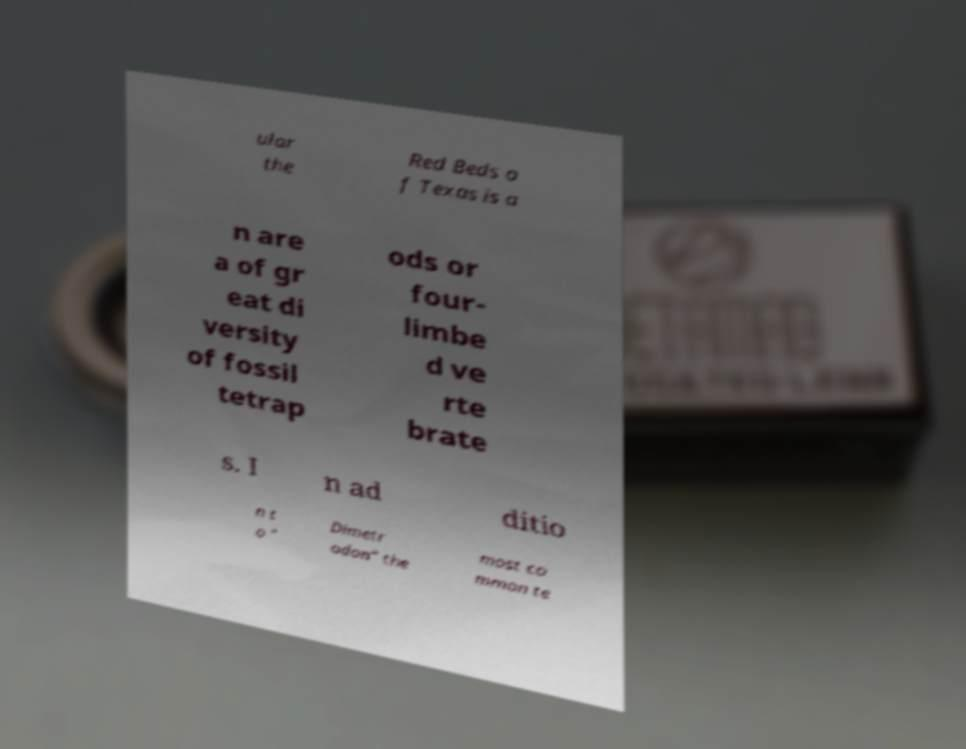Please identify and transcribe the text found in this image. ular the Red Beds o f Texas is a n are a of gr eat di versity of fossil tetrap ods or four- limbe d ve rte brate s. I n ad ditio n t o " Dimetr odon" the most co mmon te 